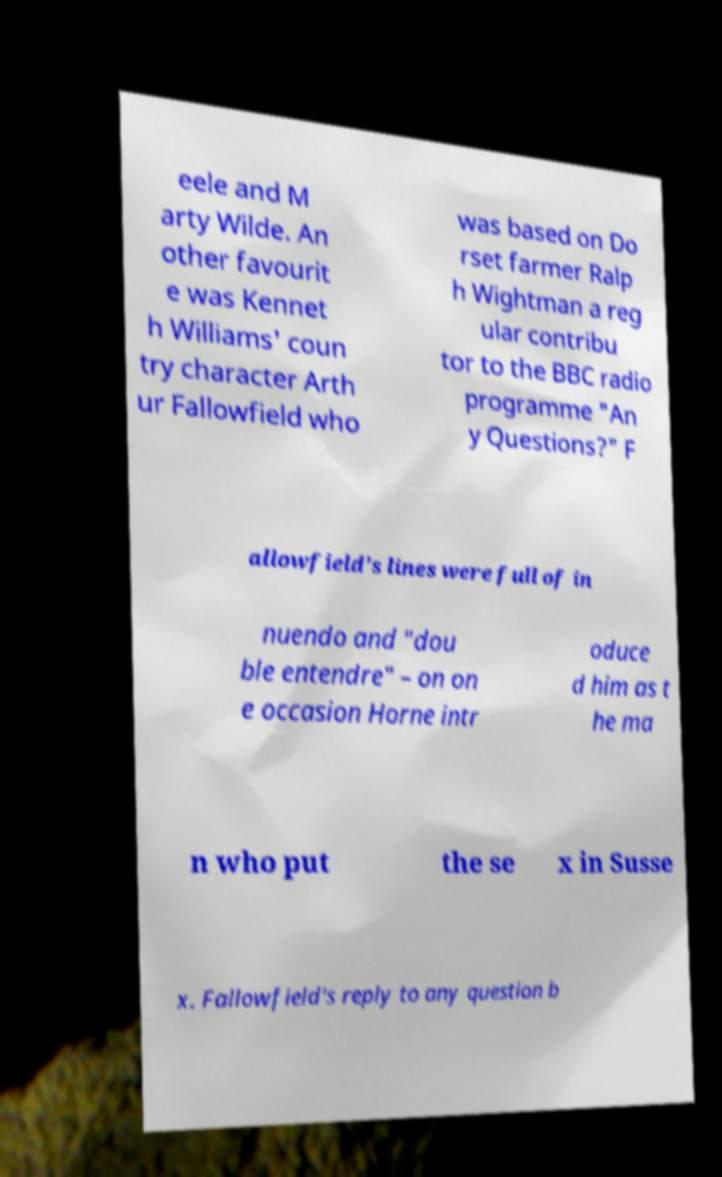Could you assist in decoding the text presented in this image and type it out clearly? eele and M arty Wilde. An other favourit e was Kennet h Williams' coun try character Arth ur Fallowfield who was based on Do rset farmer Ralp h Wightman a reg ular contribu tor to the BBC radio programme "An y Questions?" F allowfield's lines were full of in nuendo and "dou ble entendre" – on on e occasion Horne intr oduce d him as t he ma n who put the se x in Susse x. Fallowfield's reply to any question b 